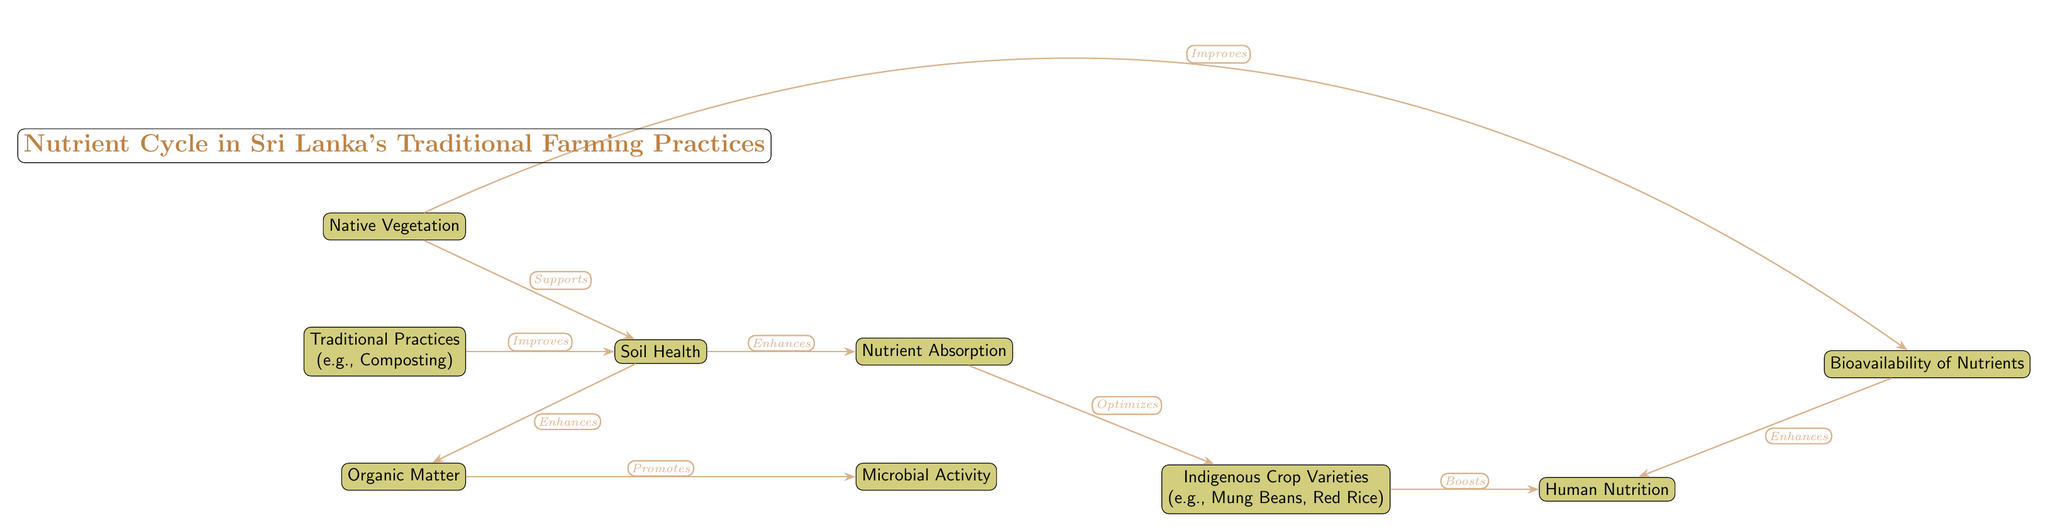What is the main title of the diagram? The main title is located at the top of the diagram and indicates the overall theme, which is the "Nutrient Cycle in Sri Lanka's Traditional Farming Practices."
Answer: Nutrient Cycle in Sri Lanka's Traditional Farming Practices How many nodes are present in the diagram? The diagram contains a total of 9 nodes, each representing a different aspect of the nutrient cycle.
Answer: 9 What enhances the organic matter according to the diagram? The diagram indicates that soil health enhances organic matter as shown by the directed edge labeled "Enhances."
Answer: Soil Health Which node improves the soil health? According to the diagram, traditional practices (like composting) are indicated to improve soil health through the directed edge labeled "Improves."
Answer: Traditional Practices What promotes microbial activity in the nutrient cycle? The diagram shows that organic matter promotes microbial activity, with a label indicating this relationship.
Answer: Organic Matter Which components contribute to human nutrition in the diagram? The diagram lists indigenous crop varieties (like mung beans and red rice) and bioavailability of nutrients as components that contribute to human nutrition, as shown by the connecting edges.
Answer: Indigenous Crop Varieties, Bioavailability of Nutrients What supports soil health in the diagram? The diagram points out that native vegetation supports soil health, as depicted by the edge labeled "Supports."
Answer: Native Vegetation How does nutrient absorption relate to crop varieties? The diagram indicates that nutrient absorption optimizes crop varieties, connecting both through the directed edge labeled "Optimizes."
Answer: Optimizes Which aspect has a direct connection to both human nutrition and bioavailability of nutrients? The diagram illustrates that bioavailability enhances human nutrition by showing a direct edge from bioavailability to human nutrition, denoting their connection.
Answer: Enhances 